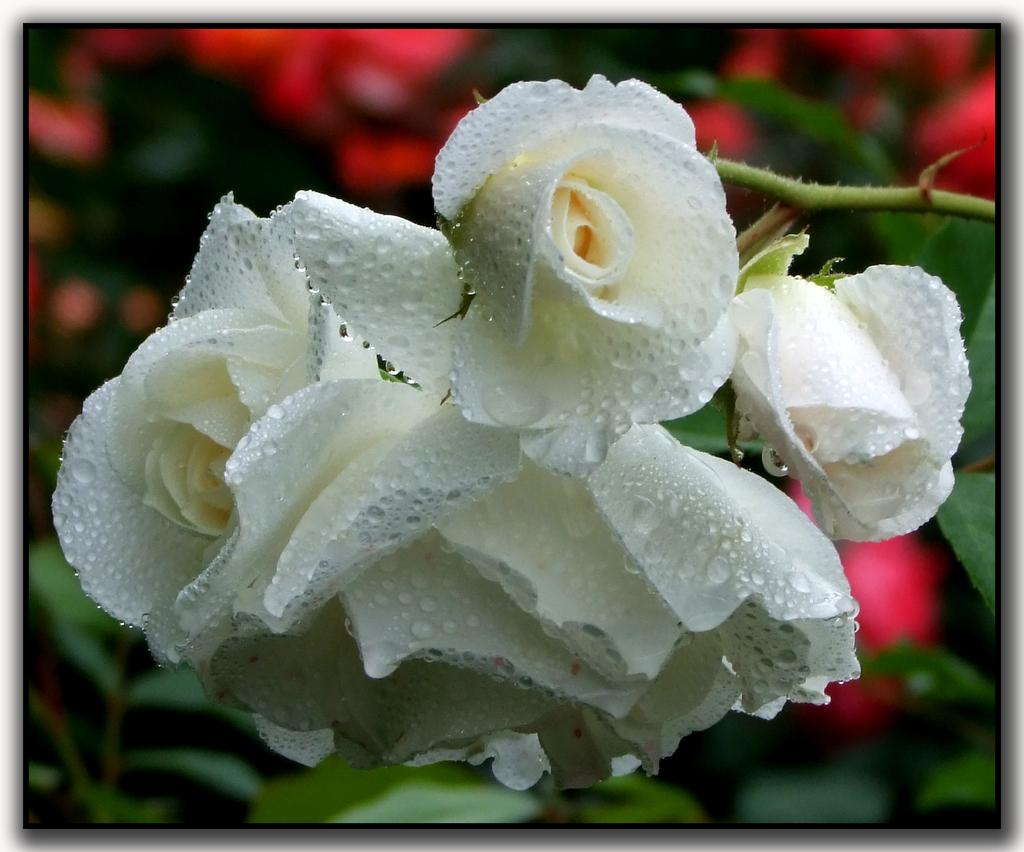What type of flowers are in the image? There are rose flowers in the image. What parts of the rose flowers are visible? The rose flowers have leaves and stems. What else can be seen behind the rose flowers? There are other flowers and leaves visible behind the rose flowers. What type of string is used to hold up the rose flowers in the image? There is no string visible in the image; the rose flowers are supported by their stems. 